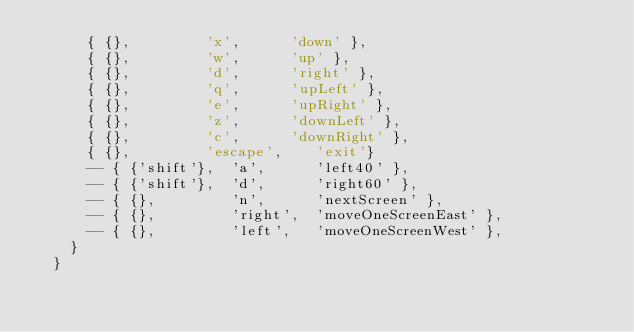Convert code to text. <code><loc_0><loc_0><loc_500><loc_500><_Lua_>      { {},         'x',      'down' },
      { {},         'w',      'up' },
      { {},         'd',      'right' },
      { {},         'q',      'upLeft' },
      { {},         'e',      'upRight' },
      { {},         'z',      'downLeft' },
      { {},         'c',      'downRight' },
      { {},         'escape',    'exit'}
      -- { {'shift'},  'a',      'left40' },
      -- { {'shift'},  'd',      'right60' },
      -- { {},         'n',      'nextScreen' },
      -- { {},         'right',  'moveOneScreenEast' },
      -- { {},         'left',   'moveOneScreenWest' },
    }
  }
  </code> 